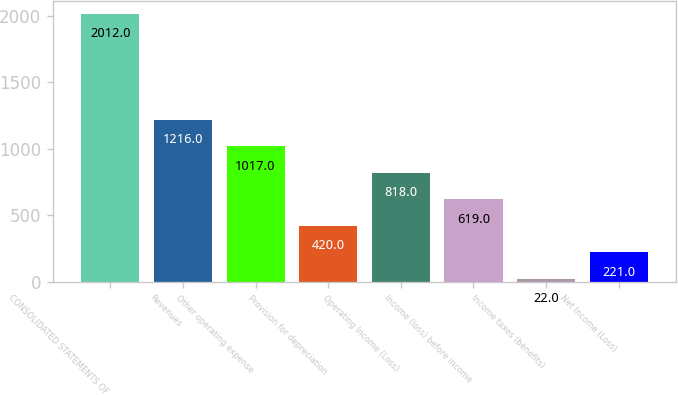Convert chart to OTSL. <chart><loc_0><loc_0><loc_500><loc_500><bar_chart><fcel>CONSOLIDATED STATEMENTS OF<fcel>Revenues<fcel>Other operating expense<fcel>Provision for depreciation<fcel>Operating Income (Loss)<fcel>Income (loss) before income<fcel>Income taxes (benefits)<fcel>Net Income (Loss)<nl><fcel>2012<fcel>1216<fcel>1017<fcel>420<fcel>818<fcel>619<fcel>22<fcel>221<nl></chart> 